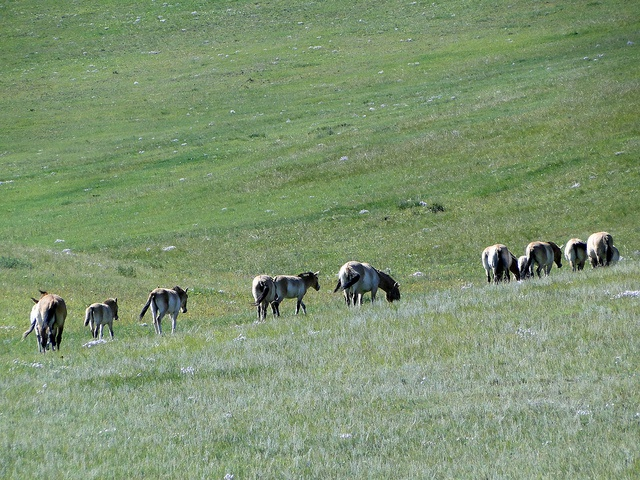Describe the objects in this image and their specific colors. I can see horse in green, black, gray, blue, and white tones, horse in green, black, gray, and darkgray tones, horse in green, black, gray, purple, and darkgray tones, horse in green, black, gray, white, and darkgray tones, and horse in green, black, gray, purple, and darkgray tones in this image. 